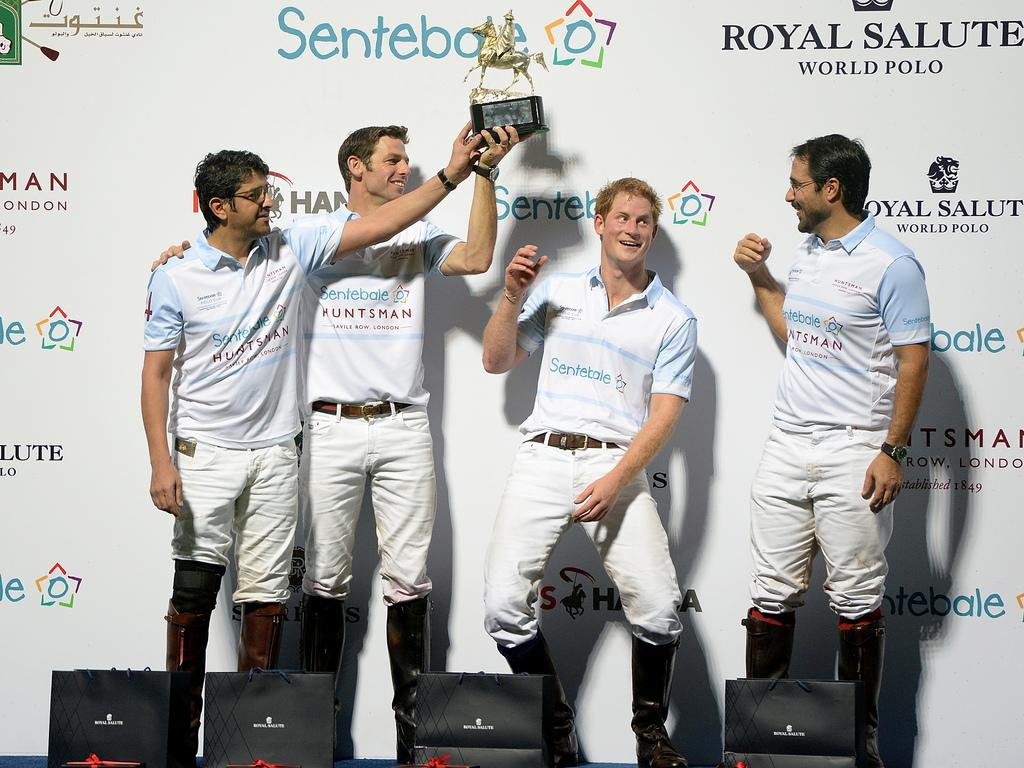<image>
Render a clear and concise summary of the photo. players holding a trophy celebrating next to a banner that says ROYAL SALUTE WORLD POLO. 